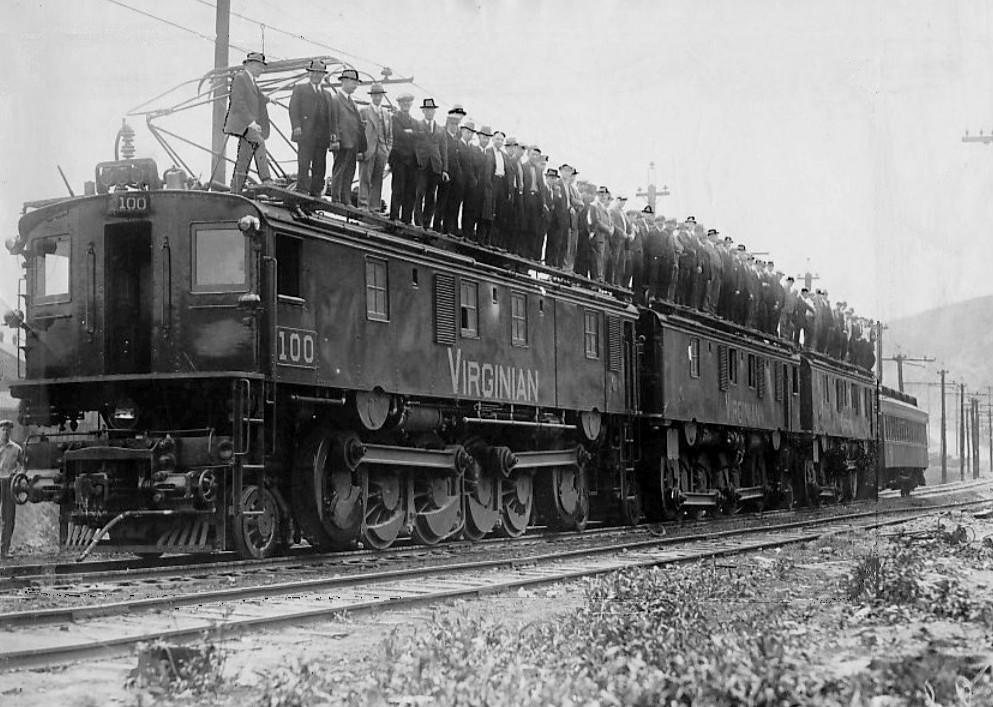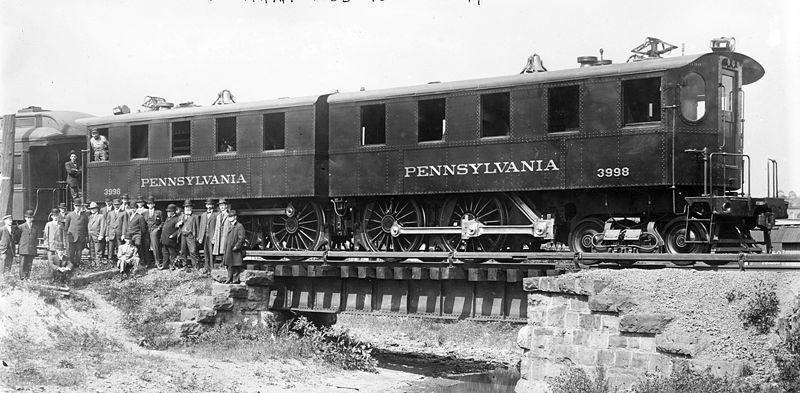The first image is the image on the left, the second image is the image on the right. Examine the images to the left and right. Is the description "In one vintage image, the engineer is visible through the window of a train heading rightward." accurate? Answer yes or no. No. 